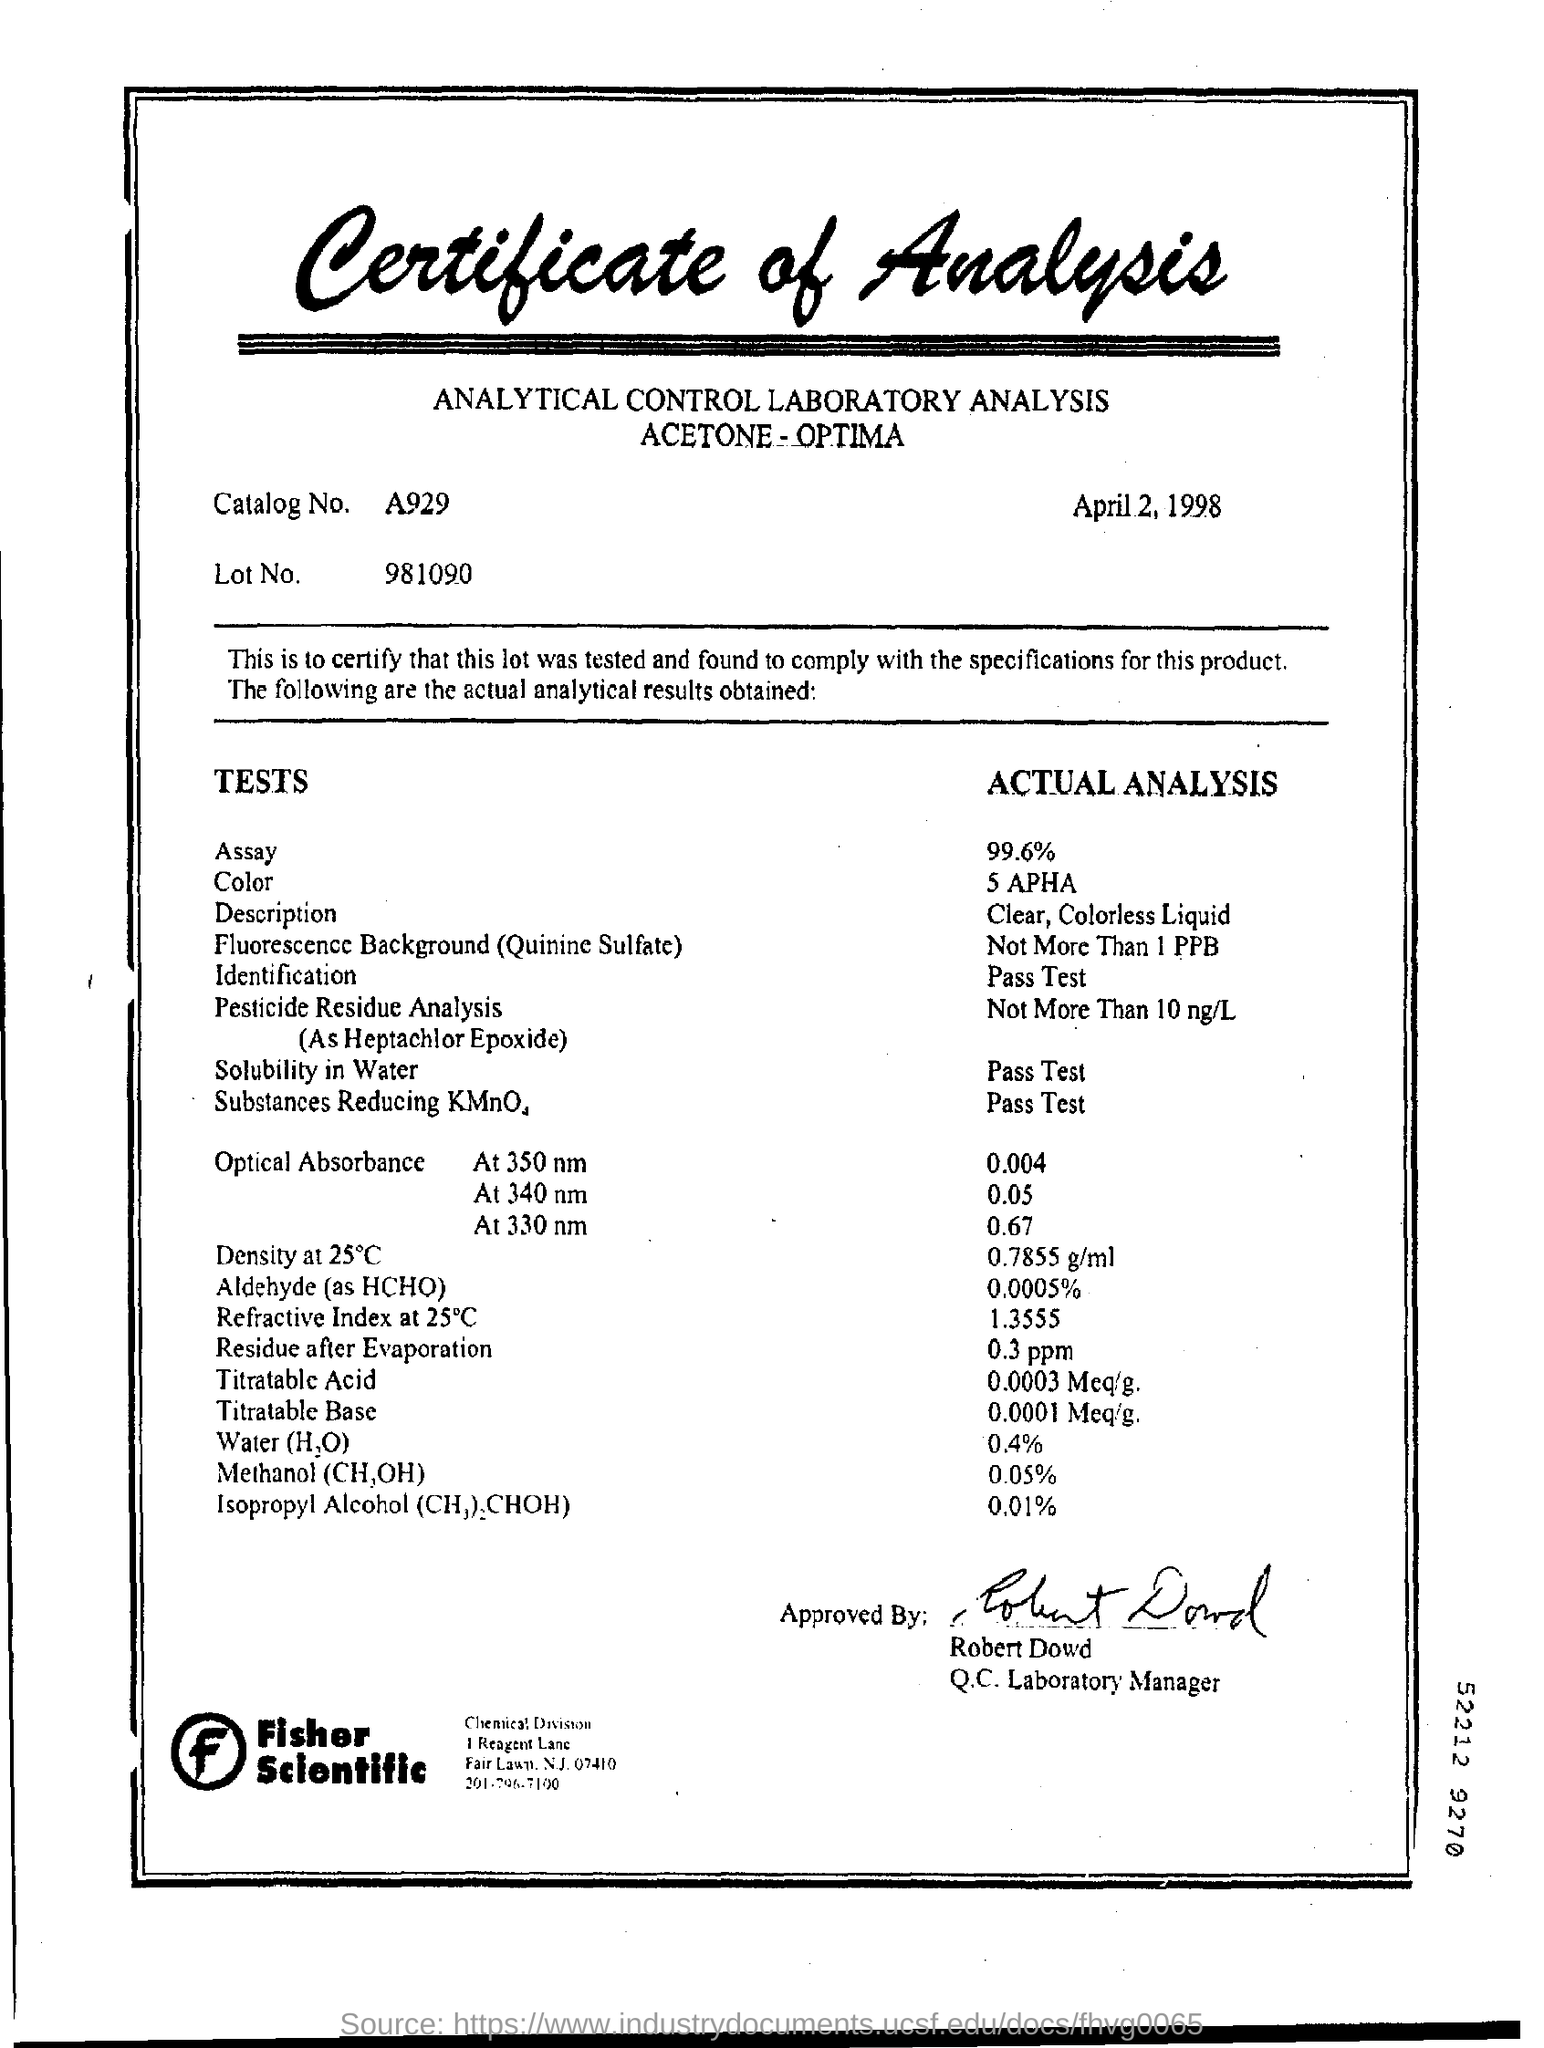When is the analysis dated?
Keep it short and to the point. April 2, 1998. What is the catalog no.?
Your answer should be compact. A929. What is the Lot no.?
Keep it short and to the point. 981090. What is the value of assay?
Keep it short and to the point. 99.6%. What is the value of residue after evaporation?
Keep it short and to the point. 0.3 ppm. Who has approved the analysis?
Make the answer very short. Robert Dowd. 